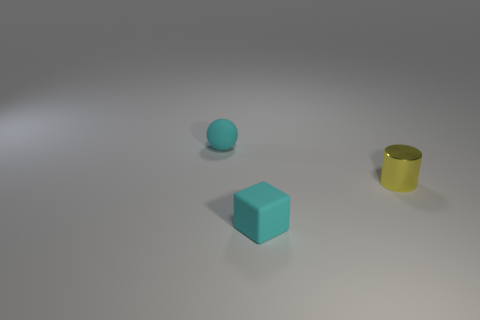Add 2 small matte spheres. How many objects exist? 5 Subtract all cylinders. How many objects are left? 2 Add 1 rubber cubes. How many rubber cubes are left? 2 Add 3 big cyan metal cylinders. How many big cyan metal cylinders exist? 3 Subtract 0 red cylinders. How many objects are left? 3 Subtract all big brown metallic cylinders. Subtract all small yellow shiny objects. How many objects are left? 2 